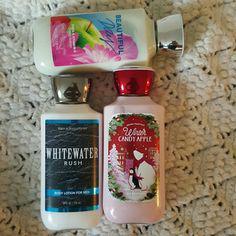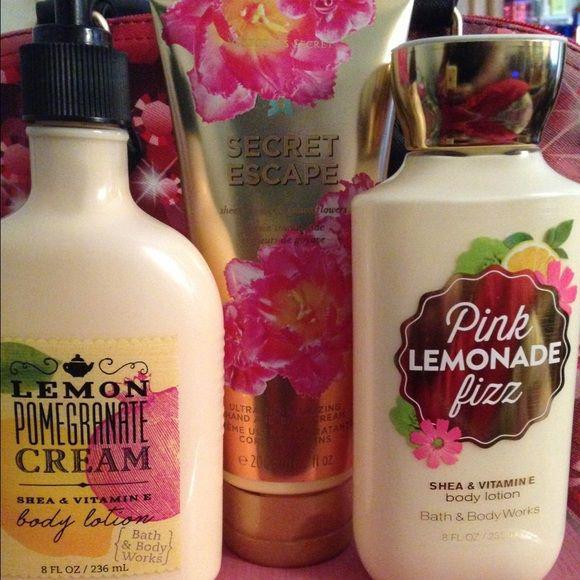The first image is the image on the left, the second image is the image on the right. For the images displayed, is the sentence "An image shows a product with orange-and-white tube-type container standing upright on its cap." factually correct? Answer yes or no. No. The first image is the image on the left, the second image is the image on the right. Evaluate the accuracy of this statement regarding the images: "The products are of the FootWorks brand.". Is it true? Answer yes or no. No. 